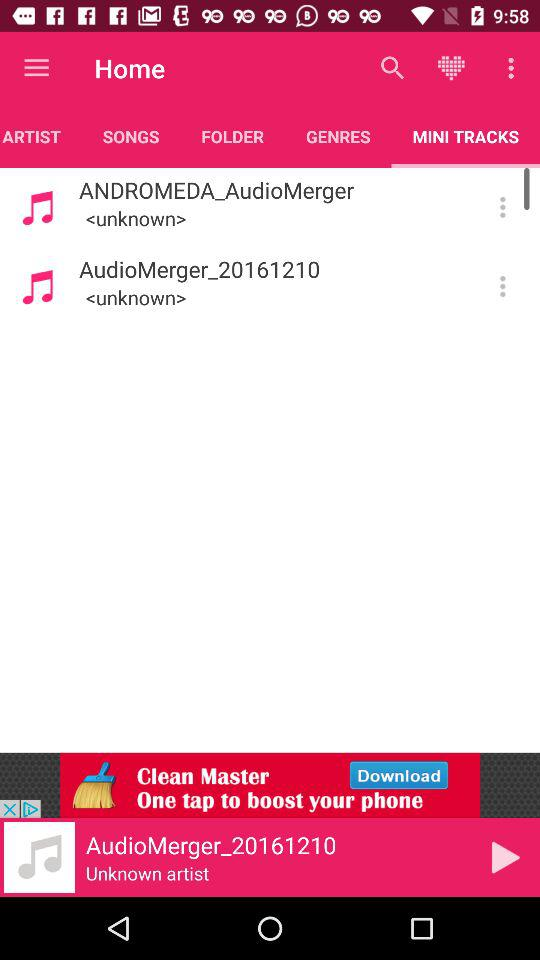Which track is currently playing? The track currently playing is "AudioMerger_20161210". 